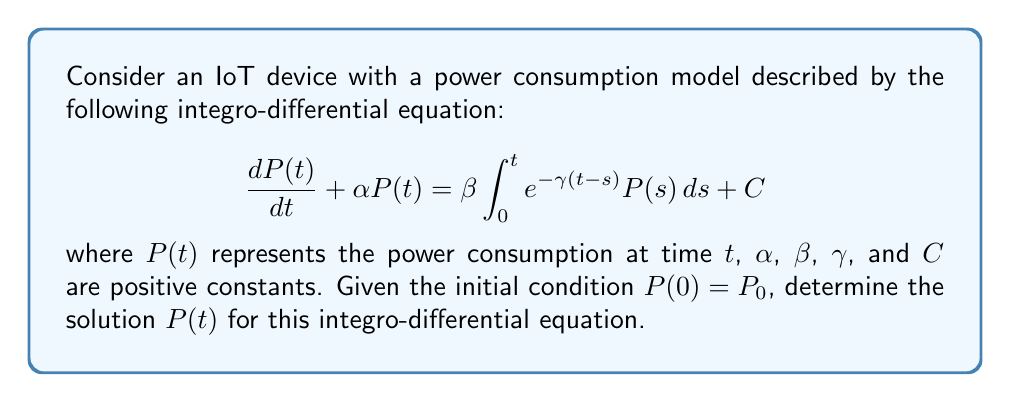Could you help me with this problem? To solve this integro-differential equation, we'll use the Laplace transform method:

1) Take the Laplace transform of both sides of the equation:
   $$\mathcal{L}\left\{\frac{dP(t)}{dt}\right\} + \alpha\mathcal{L}\{P(t)\} = \beta\mathcal{L}\left\{\int_0^t e^{-\gamma(t-s)} P(s) ds\right\} + \frac{C}{s}$$

2) Using Laplace transform properties:
   $$sP(s) - P_0 + \alpha P(s) = \beta \cdot \frac{1}{s+\gamma} \cdot P(s) + \frac{C}{s}$$

3) Rearrange the equation:
   $$(s + \alpha)P(s) - \frac{\beta}{s+\gamma}P(s) = P_0 + \frac{C}{s}$$

4) Factor out $P(s)$:
   $$P(s)\left(s + \alpha - \frac{\beta}{s+\gamma}\right) = P_0 + \frac{C}{s}$$

5) Solve for $P(s)$:
   $$P(s) = \frac{P_0 + \frac{C}{s}}{s + \alpha - \frac{\beta}{s+\gamma}}$$

6) Simplify the denominator:
   $$P(s) = \frac{(P_0s + C)(s+\gamma)}{s(s+\gamma)(s + \alpha) - \beta s}$$

7) The inverse Laplace transform of this expression gives the solution $P(t)$. The exact form depends on the roots of the cubic equation in the denominator:
   $$s(s+\gamma)(s + \alpha) - \beta s = 0$$

8) In general, the solution will have the form:
   $$P(t) = A_1e^{r_1t} + A_2e^{r_2t} + A_3e^{r_3t} + \frac{C}{\alpha}$$

   where $r_1$, $r_2$, and $r_3$ are the roots of the cubic equation, and $A_1$, $A_2$, and $A_3$ are constants determined by the initial condition and the specific values of $\alpha$, $\beta$, and $\gamma$.
Answer: $P(t) = A_1e^{r_1t} + A_2e^{r_2t} + A_3e^{r_3t} + \frac{C}{\alpha}$ 